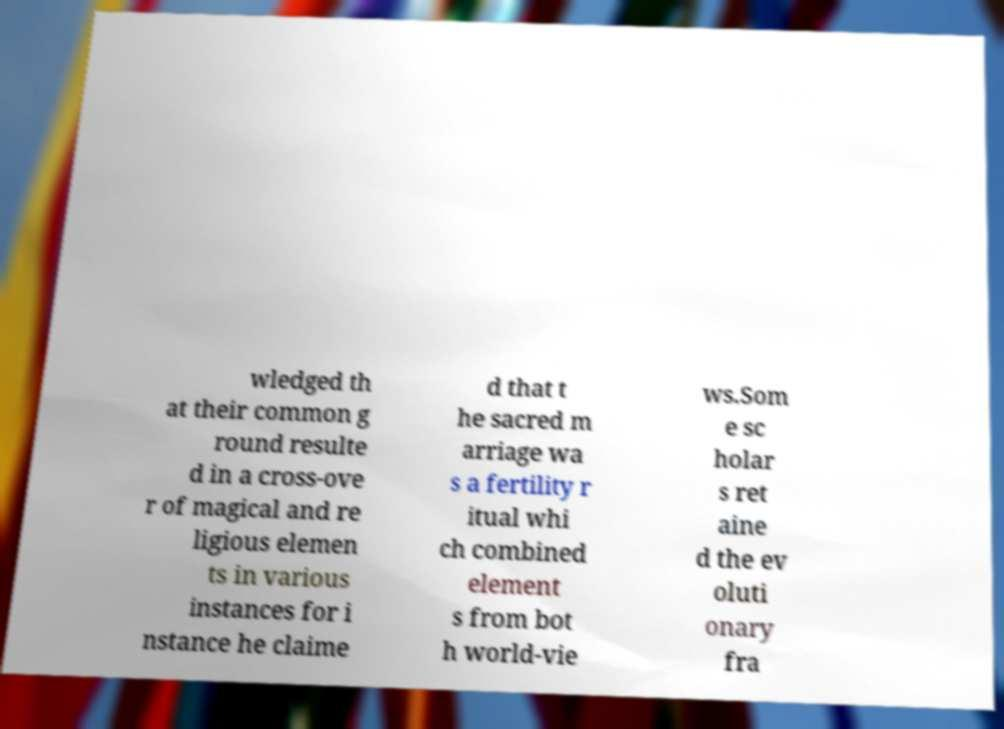There's text embedded in this image that I need extracted. Can you transcribe it verbatim? wledged th at their common g round resulte d in a cross-ove r of magical and re ligious elemen ts in various instances for i nstance he claime d that t he sacred m arriage wa s a fertility r itual whi ch combined element s from bot h world-vie ws.Som e sc holar s ret aine d the ev oluti onary fra 